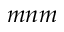Convert formula to latex. <formula><loc_0><loc_0><loc_500><loc_500>m n m</formula> 